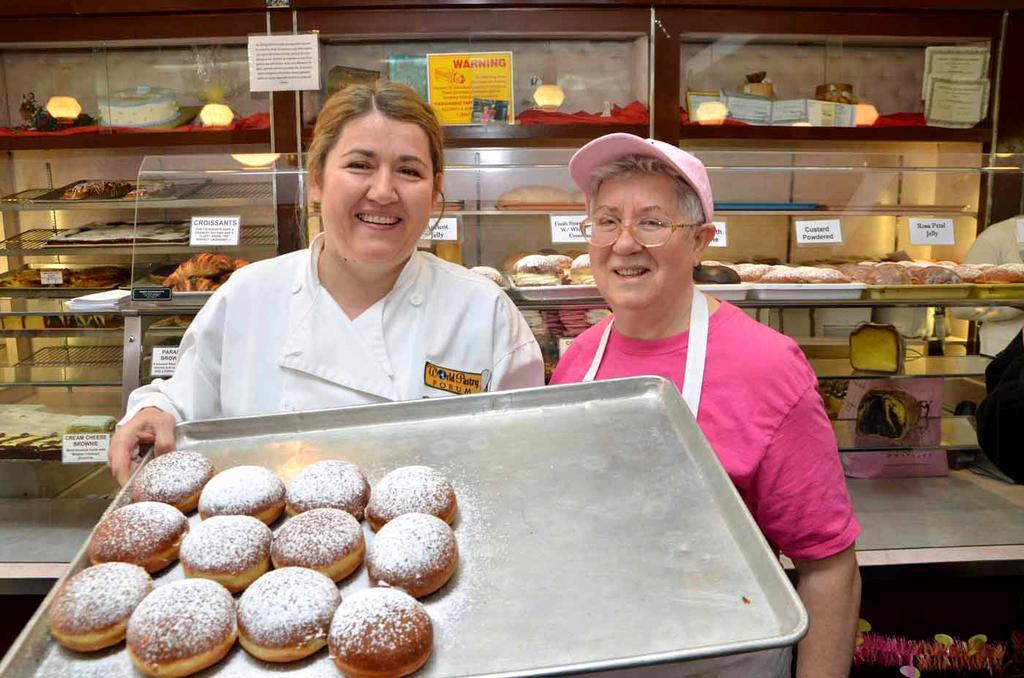Could you give a brief overview of what you see in this image? In the picture we can see two women are standing together and one woman is holding a tray with cookies in it and behind the women we can see the racks with cookies in it. 